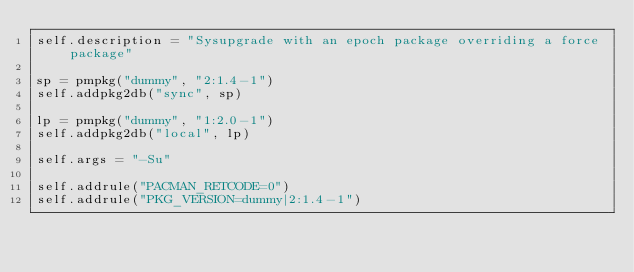<code> <loc_0><loc_0><loc_500><loc_500><_Python_>self.description = "Sysupgrade with an epoch package overriding a force package"

sp = pmpkg("dummy", "2:1.4-1")
self.addpkg2db("sync", sp)

lp = pmpkg("dummy", "1:2.0-1")
self.addpkg2db("local", lp)

self.args = "-Su"

self.addrule("PACMAN_RETCODE=0")
self.addrule("PKG_VERSION=dummy|2:1.4-1")
</code> 